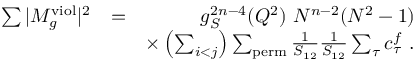Convert formula to latex. <formula><loc_0><loc_0><loc_500><loc_500>\begin{array} { r l r } { \sum | M _ { g } ^ { v i o l } | ^ { 2 } } & { = } & { g _ { S } ^ { 2 n - 4 } ( Q ^ { 2 } ) N ^ { n - 2 } ( N ^ { 2 } - 1 ) } \\ & { \times \left ( \sum _ { i < j } \right ) \sum _ { p e r m } \frac { 1 } { S _ { 1 2 } } \frac { 1 } { S _ { 1 2 } } \sum _ { \tau } c _ { \tau } ^ { f } . } \end{array}</formula> 